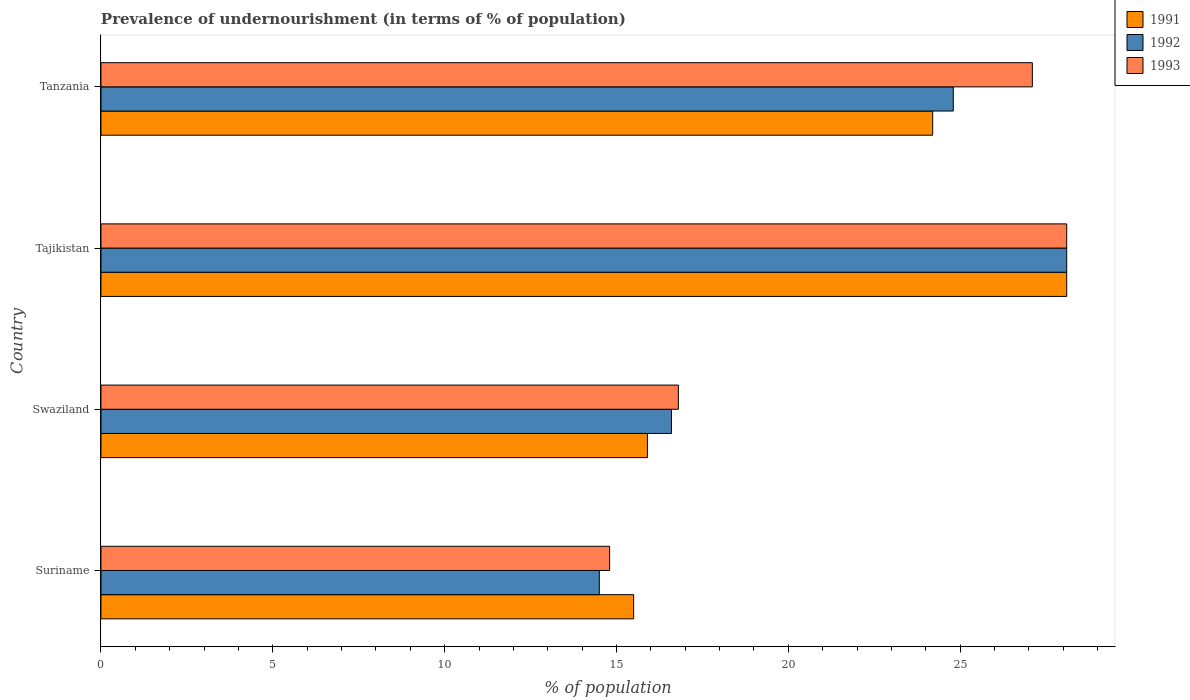Are the number of bars per tick equal to the number of legend labels?
Provide a succinct answer. Yes. How many bars are there on the 1st tick from the top?
Provide a succinct answer. 3. What is the label of the 2nd group of bars from the top?
Make the answer very short. Tajikistan. In how many cases, is the number of bars for a given country not equal to the number of legend labels?
Keep it short and to the point. 0. What is the percentage of undernourished population in 1993 in Tanzania?
Offer a terse response. 27.1. Across all countries, what is the maximum percentage of undernourished population in 1993?
Your answer should be compact. 28.1. In which country was the percentage of undernourished population in 1993 maximum?
Your answer should be compact. Tajikistan. In which country was the percentage of undernourished population in 1993 minimum?
Provide a short and direct response. Suriname. What is the total percentage of undernourished population in 1992 in the graph?
Provide a succinct answer. 84. What is the difference between the percentage of undernourished population in 1993 in Tajikistan and that in Tanzania?
Give a very brief answer. 1. What is the difference between the percentage of undernourished population in 1993 in Suriname and the percentage of undernourished population in 1991 in Tajikistan?
Your answer should be very brief. -13.3. What is the average percentage of undernourished population in 1991 per country?
Give a very brief answer. 20.93. What is the ratio of the percentage of undernourished population in 1992 in Swaziland to that in Tanzania?
Make the answer very short. 0.67. Is the percentage of undernourished population in 1992 in Tajikistan less than that in Tanzania?
Offer a very short reply. No. What is the difference between the highest and the second highest percentage of undernourished population in 1993?
Your response must be concise. 1. What is the difference between the highest and the lowest percentage of undernourished population in 1992?
Ensure brevity in your answer.  13.6. In how many countries, is the percentage of undernourished population in 1992 greater than the average percentage of undernourished population in 1992 taken over all countries?
Your response must be concise. 2. What does the 1st bar from the top in Suriname represents?
Offer a terse response. 1993. What does the 1st bar from the bottom in Suriname represents?
Your response must be concise. 1991. Is it the case that in every country, the sum of the percentage of undernourished population in 1993 and percentage of undernourished population in 1991 is greater than the percentage of undernourished population in 1992?
Your answer should be compact. Yes. Are all the bars in the graph horizontal?
Offer a terse response. Yes. What is the difference between two consecutive major ticks on the X-axis?
Provide a succinct answer. 5. Are the values on the major ticks of X-axis written in scientific E-notation?
Make the answer very short. No. Does the graph contain any zero values?
Give a very brief answer. No. How are the legend labels stacked?
Offer a very short reply. Vertical. What is the title of the graph?
Provide a succinct answer. Prevalence of undernourishment (in terms of % of population). Does "1996" appear as one of the legend labels in the graph?
Your response must be concise. No. What is the label or title of the X-axis?
Offer a very short reply. % of population. What is the % of population in 1991 in Suriname?
Keep it short and to the point. 15.5. What is the % of population in 1991 in Swaziland?
Make the answer very short. 15.9. What is the % of population in 1992 in Swaziland?
Provide a succinct answer. 16.6. What is the % of population of 1991 in Tajikistan?
Keep it short and to the point. 28.1. What is the % of population in 1992 in Tajikistan?
Give a very brief answer. 28.1. What is the % of population in 1993 in Tajikistan?
Offer a terse response. 28.1. What is the % of population in 1991 in Tanzania?
Ensure brevity in your answer.  24.2. What is the % of population in 1992 in Tanzania?
Offer a terse response. 24.8. What is the % of population of 1993 in Tanzania?
Ensure brevity in your answer.  27.1. Across all countries, what is the maximum % of population of 1991?
Make the answer very short. 28.1. Across all countries, what is the maximum % of population of 1992?
Give a very brief answer. 28.1. Across all countries, what is the maximum % of population of 1993?
Provide a short and direct response. 28.1. What is the total % of population of 1991 in the graph?
Ensure brevity in your answer.  83.7. What is the total % of population in 1993 in the graph?
Offer a very short reply. 86.8. What is the difference between the % of population of 1991 in Suriname and that in Swaziland?
Provide a short and direct response. -0.4. What is the difference between the % of population in 1991 in Suriname and that in Tajikistan?
Provide a short and direct response. -12.6. What is the difference between the % of population in 1992 in Suriname and that in Tajikistan?
Your answer should be compact. -13.6. What is the difference between the % of population of 1991 in Suriname and that in Tanzania?
Ensure brevity in your answer.  -8.7. What is the difference between the % of population of 1992 in Suriname and that in Tanzania?
Your answer should be compact. -10.3. What is the difference between the % of population of 1992 in Swaziland and that in Tajikistan?
Provide a short and direct response. -11.5. What is the difference between the % of population of 1993 in Swaziland and that in Tajikistan?
Offer a very short reply. -11.3. What is the difference between the % of population of 1991 in Swaziland and that in Tanzania?
Ensure brevity in your answer.  -8.3. What is the difference between the % of population of 1992 in Swaziland and that in Tanzania?
Provide a succinct answer. -8.2. What is the difference between the % of population in 1991 in Suriname and the % of population in 1992 in Swaziland?
Give a very brief answer. -1.1. What is the difference between the % of population of 1991 in Suriname and the % of population of 1993 in Tajikistan?
Offer a terse response. -12.6. What is the difference between the % of population in 1991 in Suriname and the % of population in 1992 in Tanzania?
Provide a succinct answer. -9.3. What is the difference between the % of population in 1991 in Swaziland and the % of population in 1992 in Tajikistan?
Provide a short and direct response. -12.2. What is the difference between the % of population in 1991 in Swaziland and the % of population in 1993 in Tajikistan?
Your answer should be very brief. -12.2. What is the difference between the % of population in 1992 in Swaziland and the % of population in 1993 in Tajikistan?
Provide a succinct answer. -11.5. What is the difference between the % of population in 1991 in Swaziland and the % of population in 1993 in Tanzania?
Provide a short and direct response. -11.2. What is the difference between the % of population in 1991 in Tajikistan and the % of population in 1992 in Tanzania?
Give a very brief answer. 3.3. What is the difference between the % of population of 1991 in Tajikistan and the % of population of 1993 in Tanzania?
Provide a succinct answer. 1. What is the difference between the % of population of 1992 in Tajikistan and the % of population of 1993 in Tanzania?
Offer a very short reply. 1. What is the average % of population in 1991 per country?
Offer a very short reply. 20.93. What is the average % of population in 1993 per country?
Your answer should be very brief. 21.7. What is the difference between the % of population of 1991 and % of population of 1992 in Suriname?
Provide a short and direct response. 1. What is the difference between the % of population of 1991 and % of population of 1993 in Suriname?
Your response must be concise. 0.7. What is the difference between the % of population in 1992 and % of population in 1993 in Suriname?
Offer a very short reply. -0.3. What is the difference between the % of population of 1991 and % of population of 1992 in Swaziland?
Offer a very short reply. -0.7. What is the difference between the % of population of 1991 and % of population of 1993 in Tajikistan?
Provide a succinct answer. 0. What is the difference between the % of population in 1991 and % of population in 1992 in Tanzania?
Keep it short and to the point. -0.6. What is the difference between the % of population of 1991 and % of population of 1993 in Tanzania?
Provide a short and direct response. -2.9. What is the ratio of the % of population in 1991 in Suriname to that in Swaziland?
Make the answer very short. 0.97. What is the ratio of the % of population of 1992 in Suriname to that in Swaziland?
Ensure brevity in your answer.  0.87. What is the ratio of the % of population of 1993 in Suriname to that in Swaziland?
Provide a succinct answer. 0.88. What is the ratio of the % of population in 1991 in Suriname to that in Tajikistan?
Offer a terse response. 0.55. What is the ratio of the % of population in 1992 in Suriname to that in Tajikistan?
Keep it short and to the point. 0.52. What is the ratio of the % of population in 1993 in Suriname to that in Tajikistan?
Ensure brevity in your answer.  0.53. What is the ratio of the % of population of 1991 in Suriname to that in Tanzania?
Offer a very short reply. 0.64. What is the ratio of the % of population in 1992 in Suriname to that in Tanzania?
Offer a very short reply. 0.58. What is the ratio of the % of population of 1993 in Suriname to that in Tanzania?
Ensure brevity in your answer.  0.55. What is the ratio of the % of population of 1991 in Swaziland to that in Tajikistan?
Give a very brief answer. 0.57. What is the ratio of the % of population of 1992 in Swaziland to that in Tajikistan?
Make the answer very short. 0.59. What is the ratio of the % of population in 1993 in Swaziland to that in Tajikistan?
Ensure brevity in your answer.  0.6. What is the ratio of the % of population of 1991 in Swaziland to that in Tanzania?
Give a very brief answer. 0.66. What is the ratio of the % of population in 1992 in Swaziland to that in Tanzania?
Keep it short and to the point. 0.67. What is the ratio of the % of population of 1993 in Swaziland to that in Tanzania?
Ensure brevity in your answer.  0.62. What is the ratio of the % of population in 1991 in Tajikistan to that in Tanzania?
Offer a terse response. 1.16. What is the ratio of the % of population of 1992 in Tajikistan to that in Tanzania?
Your answer should be compact. 1.13. What is the ratio of the % of population in 1993 in Tajikistan to that in Tanzania?
Offer a terse response. 1.04. What is the difference between the highest and the second highest % of population of 1991?
Give a very brief answer. 3.9. What is the difference between the highest and the second highest % of population of 1992?
Make the answer very short. 3.3. What is the difference between the highest and the second highest % of population of 1993?
Your answer should be compact. 1. What is the difference between the highest and the lowest % of population in 1991?
Offer a terse response. 12.6. What is the difference between the highest and the lowest % of population of 1993?
Give a very brief answer. 13.3. 